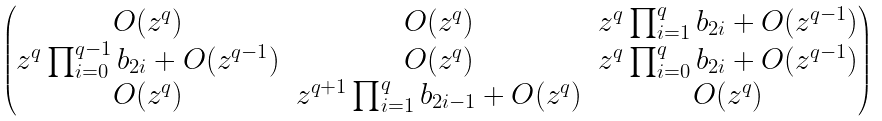<formula> <loc_0><loc_0><loc_500><loc_500>\begin{pmatrix} O ( z ^ { q } ) & O ( z ^ { q } ) & z ^ { q } \prod _ { i = 1 } ^ { q } b _ { 2 i } + O ( z ^ { q - 1 } ) \\ z ^ { q } \prod _ { i = 0 } ^ { q - 1 } b _ { 2 i } + O ( z ^ { q - 1 } ) & O ( z ^ { q } ) & z ^ { q } \prod _ { i = 0 } ^ { q } b _ { 2 i } + O ( z ^ { q - 1 } ) \\ O ( z ^ { q } ) & z ^ { q + 1 } \prod _ { i = 1 } ^ { q } b _ { 2 i - 1 } + O ( z ^ { q } ) & O ( z ^ { q } ) \end{pmatrix}</formula> 